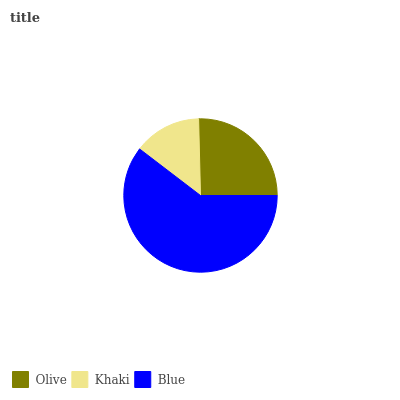Is Khaki the minimum?
Answer yes or no. Yes. Is Blue the maximum?
Answer yes or no. Yes. Is Blue the minimum?
Answer yes or no. No. Is Khaki the maximum?
Answer yes or no. No. Is Blue greater than Khaki?
Answer yes or no. Yes. Is Khaki less than Blue?
Answer yes or no. Yes. Is Khaki greater than Blue?
Answer yes or no. No. Is Blue less than Khaki?
Answer yes or no. No. Is Olive the high median?
Answer yes or no. Yes. Is Olive the low median?
Answer yes or no. Yes. Is Khaki the high median?
Answer yes or no. No. Is Khaki the low median?
Answer yes or no. No. 